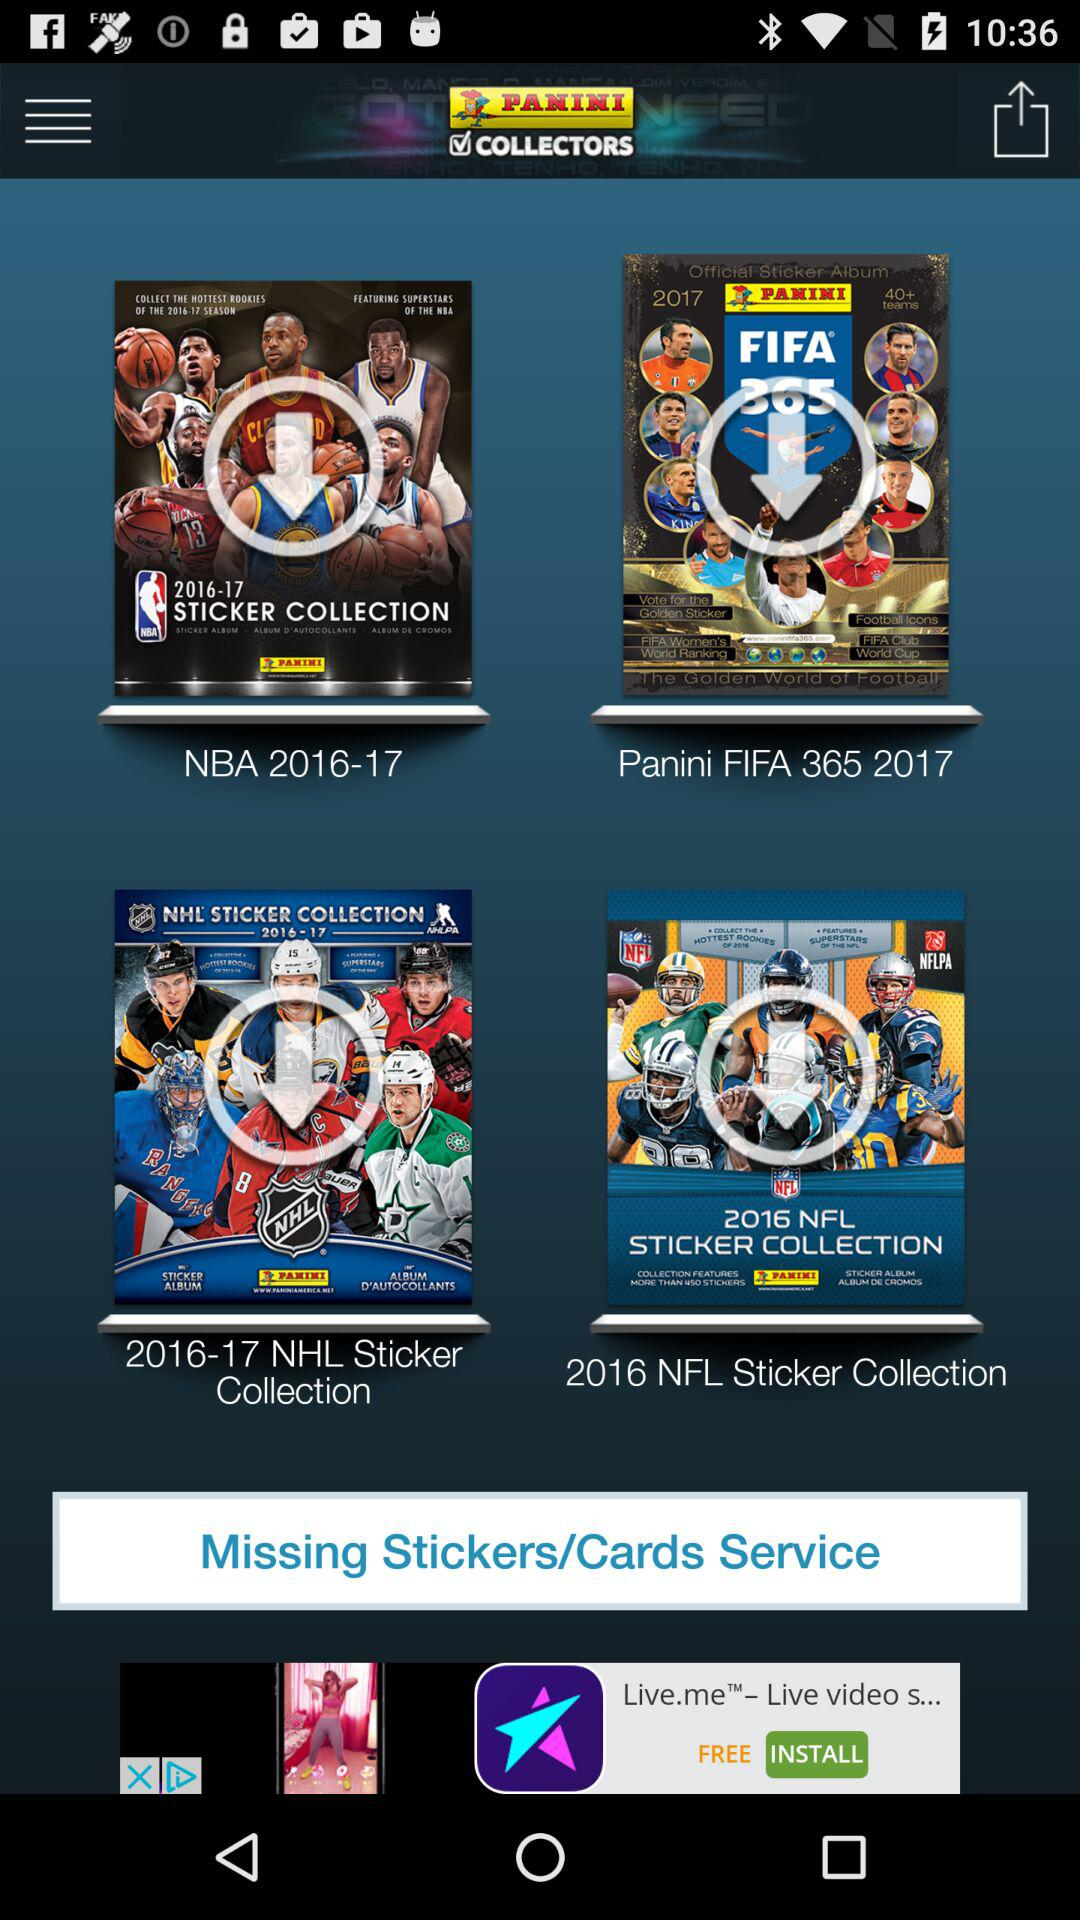What is the name of the application? The name of the application is "PANINI COLLECTORS". 